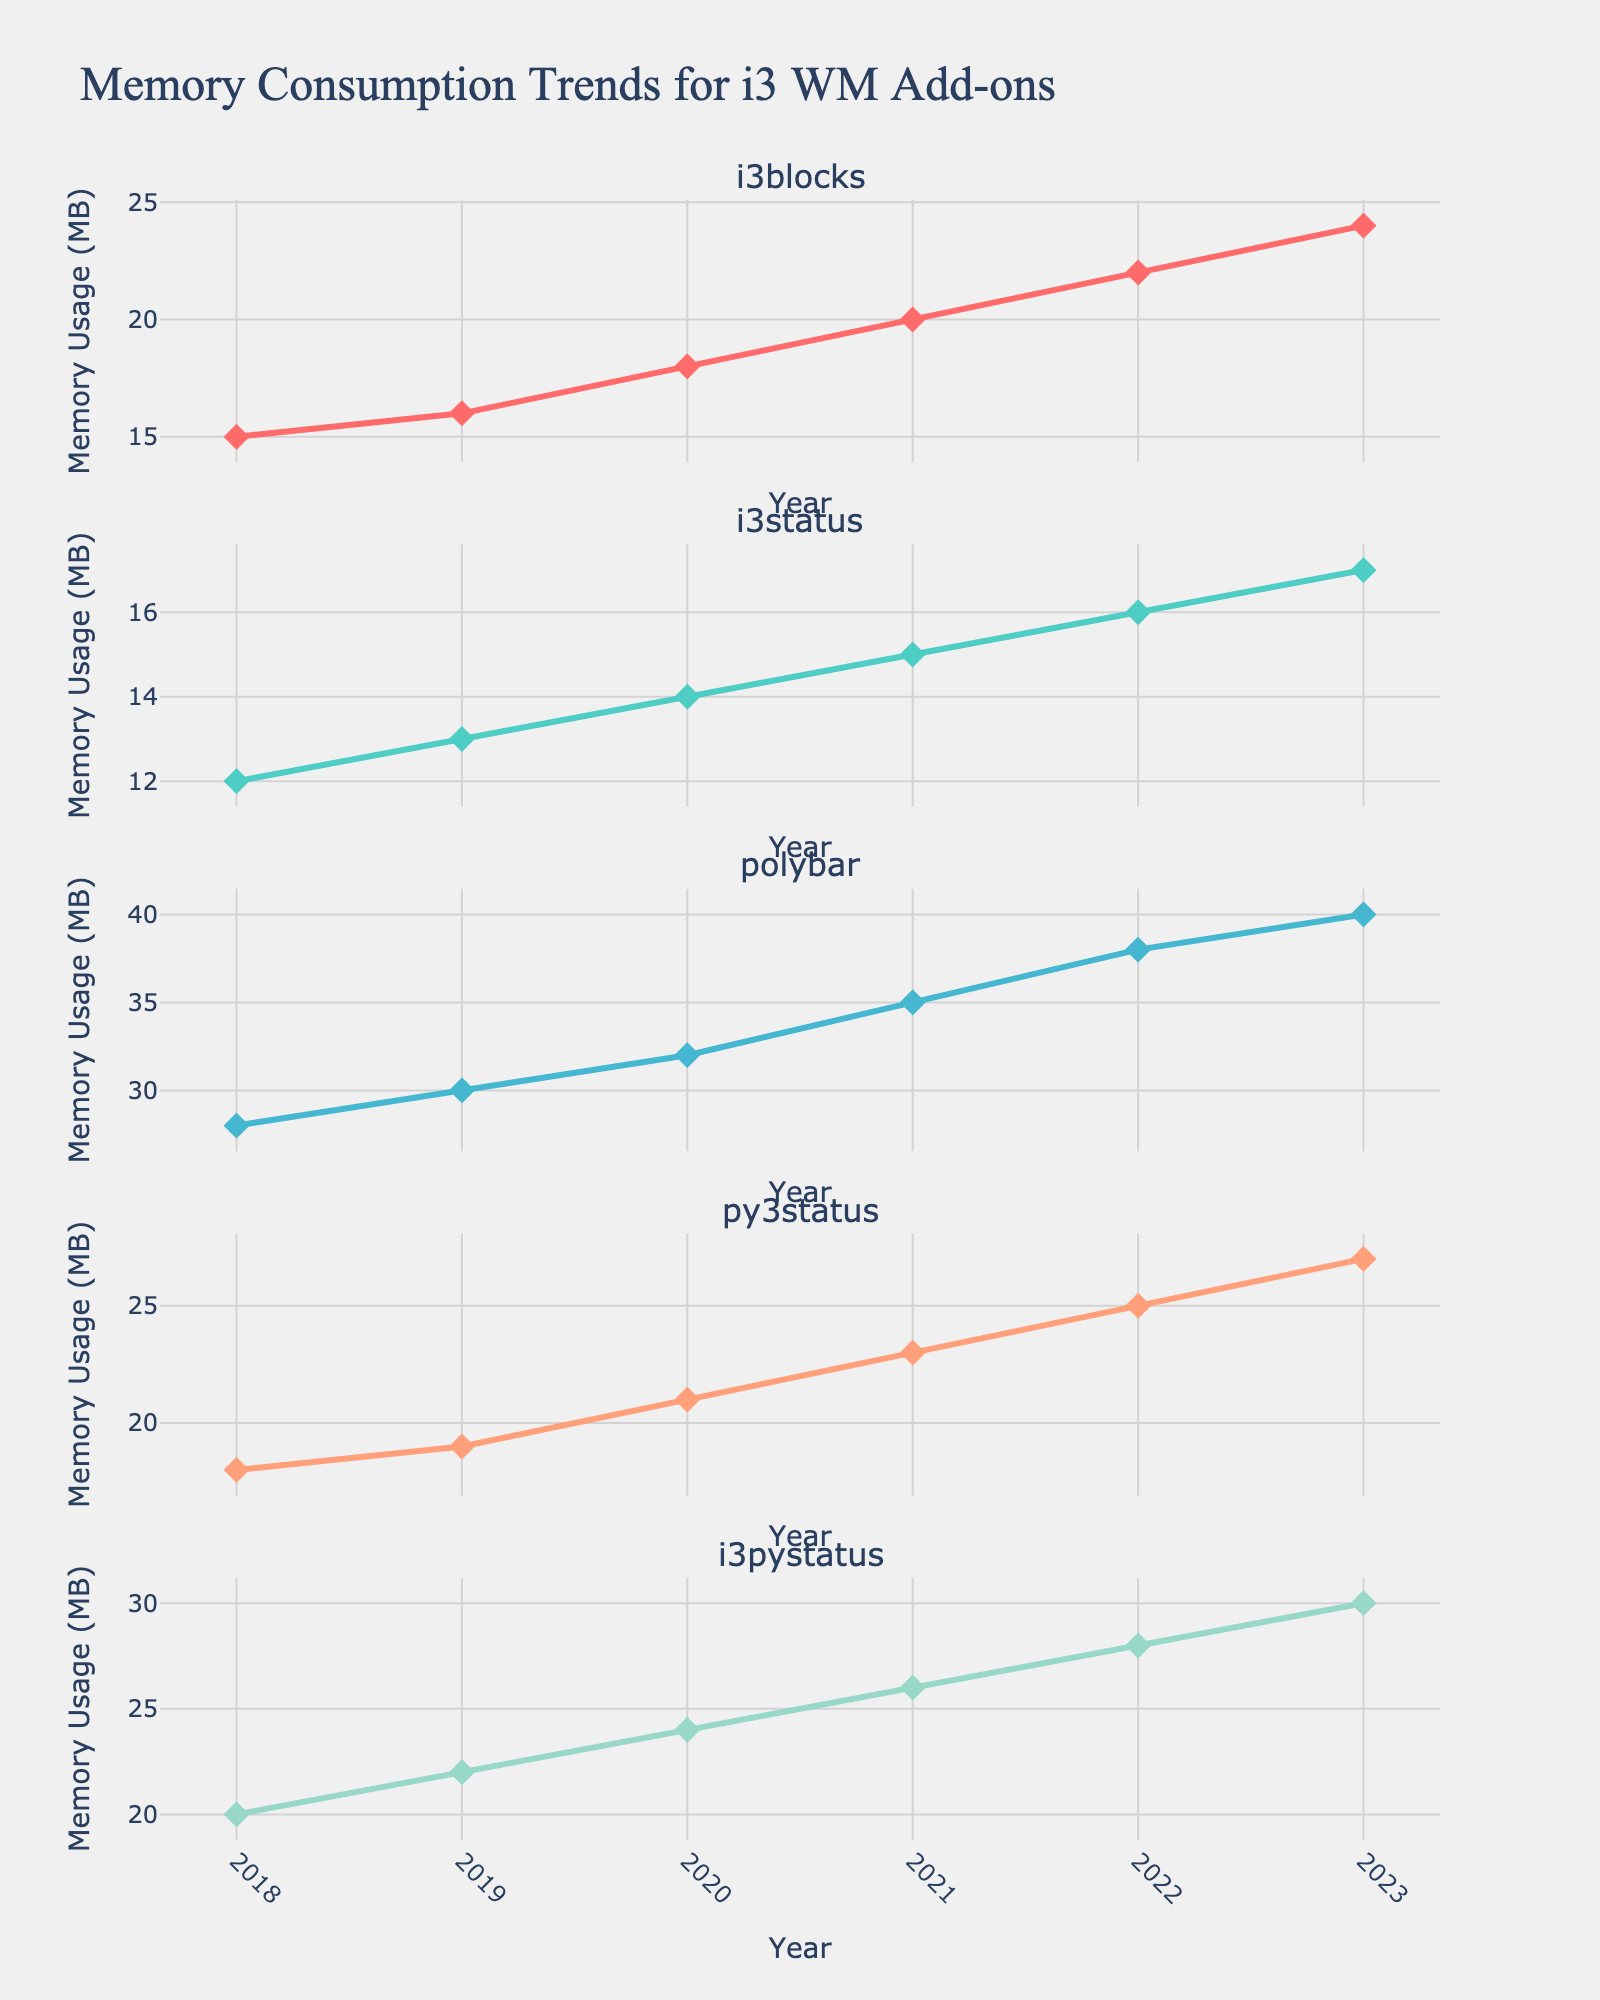What's the title of the figure? The title is usually displayed at the top of the figure. Here, we can see it reads "French Athletes' Olympic Performances (2012-2020)".
Answer: French Athletes' Olympic Performances (2012-2020) Which athlete in the Swimming sport has a "Did Not Compete" record for 2020? Look for the data points in the Swimming subplot, then identify which athlete has "Did Not Compete" as their marker for 2020.
Answer: Camille Lacourt Who won gold medals in Handball in both 2012 and 2020? Check the Handball subplot for gold-colored markers in 2012 and 2020. The athlete with gold markers in both years is the answer.
Answer: Nikola Karabatic How many total medals did Teddy Riner win from 2012 to 2020? Count the total number of medals (gold, silver, bronze) associated with Teddy Riner from all three years.
Answer: Three Comparing the Athletics subplot, which athlete had a downward performance trend from 2012 to 2020? Identify athletes in the Athletics subplot and note their medal types over the years. A downward trend means moving from higher value medals (gold) to lower (silver, bronze, or none).
Answer: Renaud Lavillenie In Judo, did either athlete improve their performance from 2012 to 2020? Look at the performance markers for Judo athletes from 2012 to 2020. Improvement means moving from no medal to higher-value medals (bronze, silver, gold).
Answer: Clarisse Agbegnenou Count the number of athletes who won a medal in the 2020 Olympics. Scan all subplots for athletes with markers indicating medals (gold, silver, bronze) in 2020 and count them.
Answer: Seven In which sport did an athlete win a medal in all three Olympic Games from 2012 to 2020? For each sport, identify if there's an athlete with medals in every game year.
Answer: Judo Who was the only athlete to win a silver medal in all three games they competed in? Look across all subplots for an athlete consistently marked with silver for all years they participated.
Answer: Kevin Mayer Which sport had the most diverse range of performance outcomes (gold, silver, bronze, no medal, did not compete)? Evaluate each subplot to see which has the most variety in performance markers across different years.
Answer: Swimming 